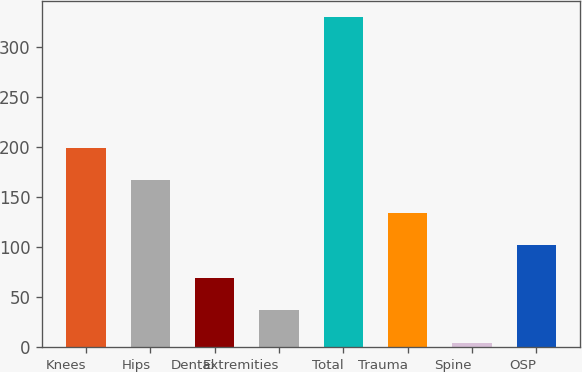Convert chart. <chart><loc_0><loc_0><loc_500><loc_500><bar_chart><fcel>Knees<fcel>Hips<fcel>Dental<fcel>Extremities<fcel>Total<fcel>Trauma<fcel>Spine<fcel>OSP<nl><fcel>199.72<fcel>167.2<fcel>69.64<fcel>37.12<fcel>329.8<fcel>134.68<fcel>4.6<fcel>102.16<nl></chart> 